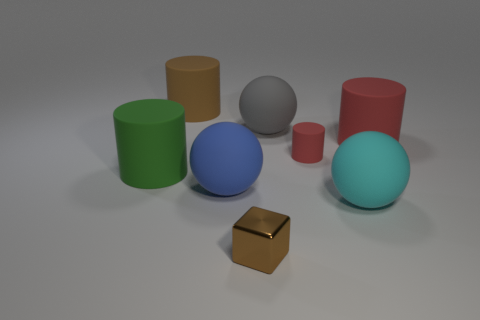Are the small object on the right side of the small brown block and the large cyan ball made of the same material? While both the small object to the right of the brown block and the large cyan ball exhibit a smooth and shiny texture, suggesting they could be made of a similar glossy material such as plastic, it's not possible to determine with absolute certainty they are made of the exact same material solely based on the image. 